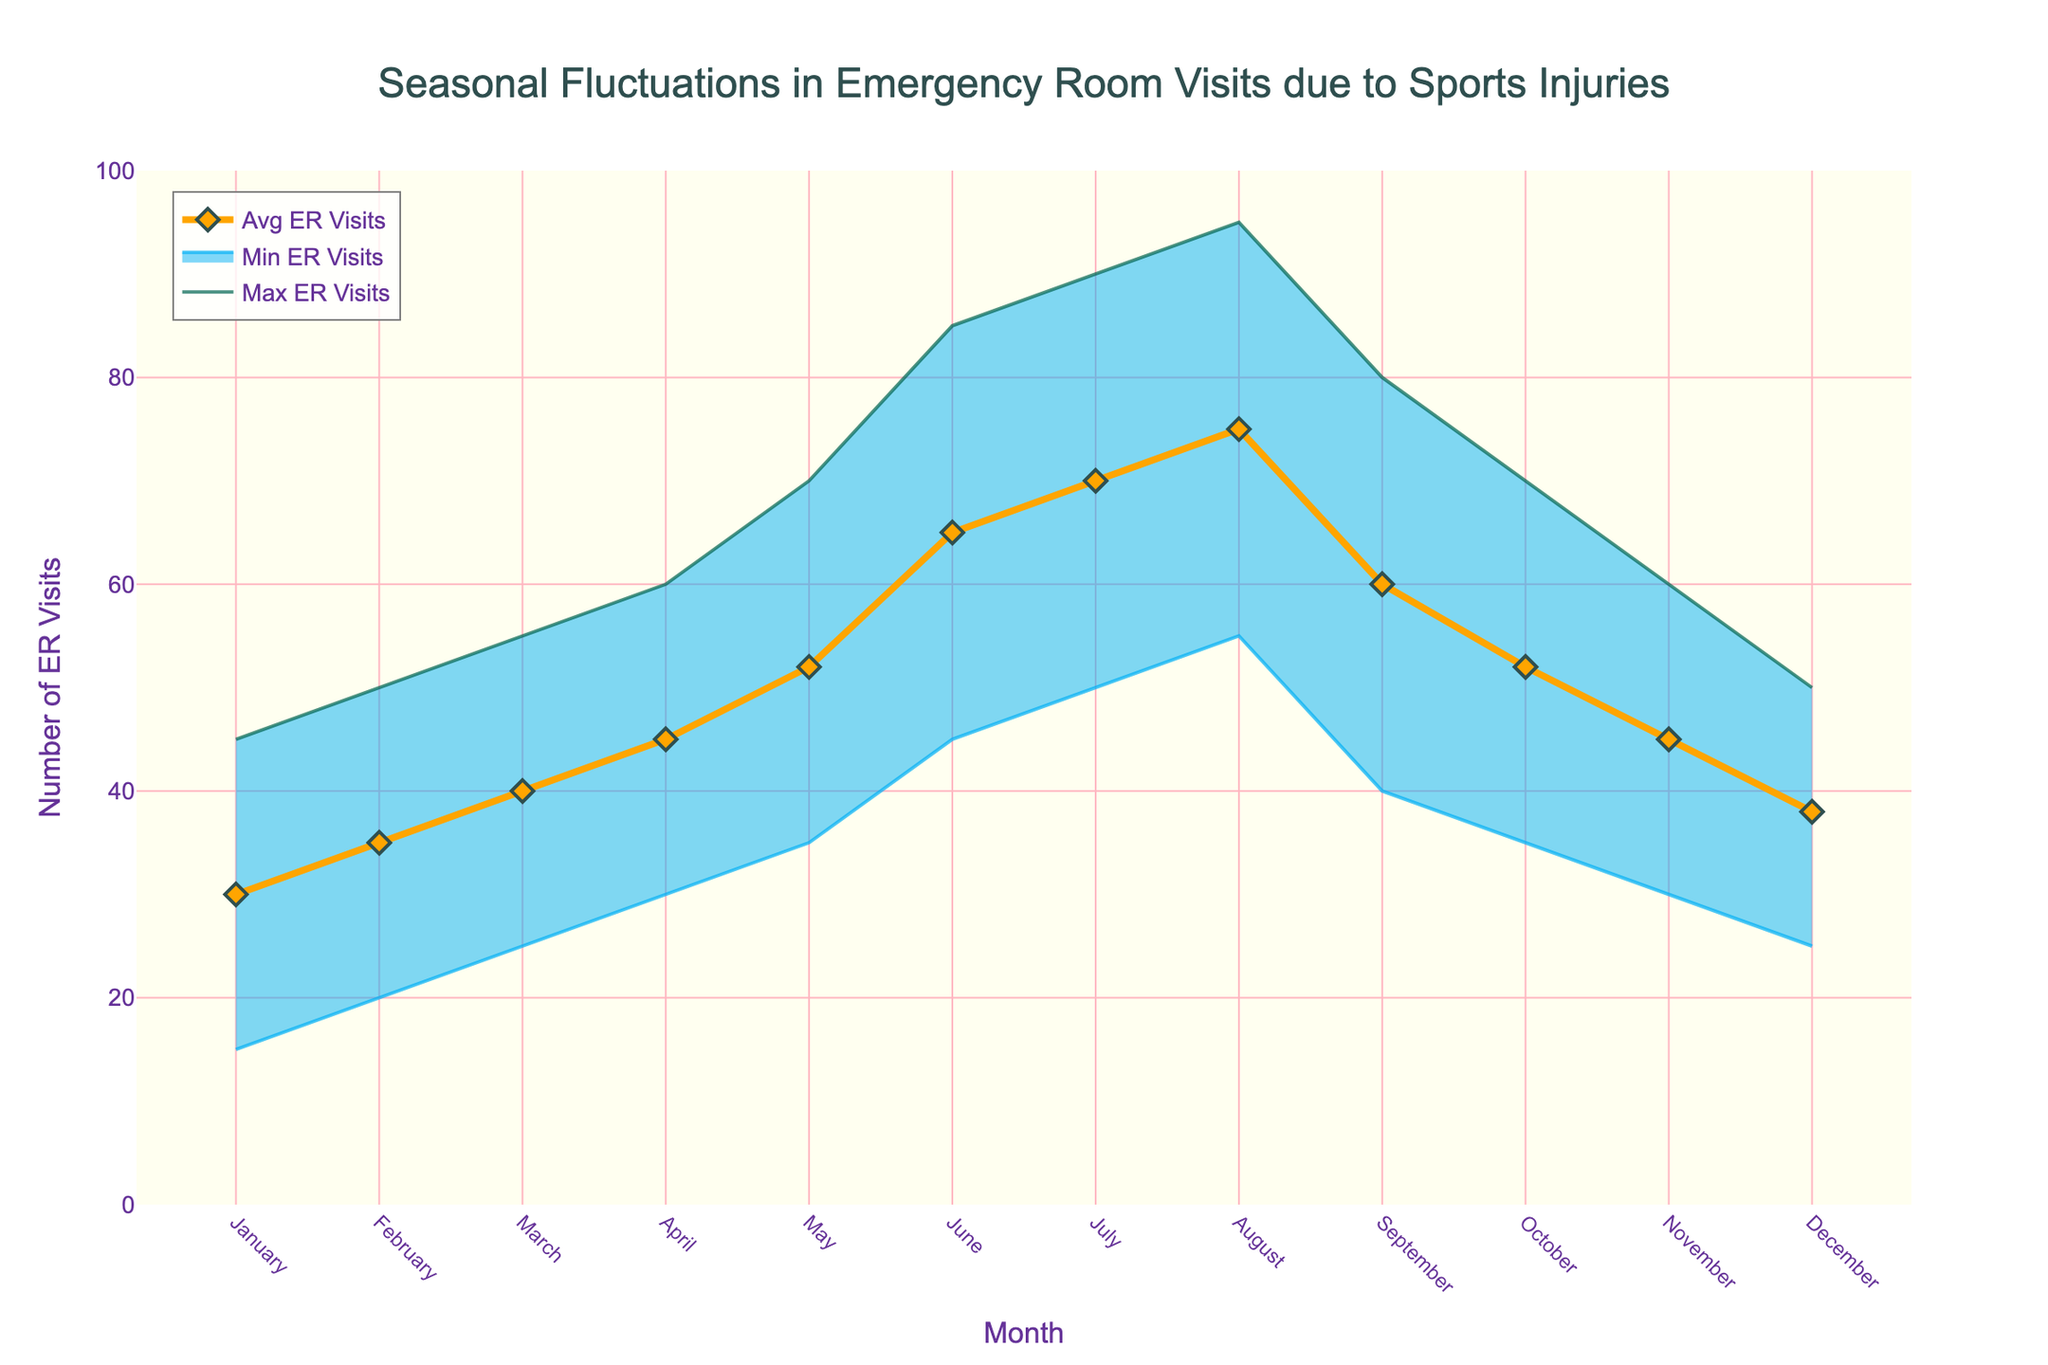What's the title of the figure? The figure's title can be found at the very top and typically encompasses the overarching theme or focus of the graph.
Answer: Seasonal Fluctuations in Emergency Room Visits due to Sports Injuries What are the y-axis and x-axis titles? The titles of the y-axis and x-axis are located near the respective axes and describe what is being measured and the units of the measurements.
Answer: The y-axis title is "Number of ER Visits" and the x-axis title is "Month" During which month is the difference between the maximum and minimum number of ER visits the largest? To determine the month with the largest difference between maximum and minimum ER visits, we need to find the month where the subtraction (Max ER Visits - Min ER Visits) is the highest. The data shows the largest difference (95 - 55 = 40) in August.
Answer: August Which months have the same average number of ER visits? To find the months with the same average ER visits, we compare the average values across all months. From the data, we can see that May and October both have an average of 52 ER visits.
Answer: May and October What is the general trend of average ER visits from January to December? To describe the general trend, we observe the average values: the average number of ER visits starts at 30 in January, generally increases to a peak in August (75), and then decreases again by December (38).
Answer: Increase to August, then decrease Which month experiences the least fluctuation in ER visits? The month with the least fluctuation in ER visits is identified by finding the smallest difference between the max and min values (range). The month with the smallest fluctuation is January (45 - 15 = 30).
Answer: January How many months have an average number of ER visits less than 40? To answer this, we count the months with average ER visits below 40 from the dataset: January (30), February (35), and December (38). So, there are 3 months.
Answer: 3 months During which months did the average number of ER visits exceed 60? Observing the months where Avg ER Visits > 60 reveals that June (65), July (70), and August (75) meet this criterion.
Answer: June, July, and August What is the difference in average ER visits between December and January? To find this, we subtract the average ER visits of January (30) from December (38). The difference is 38 - 30 = 8.
Answer: 8 In which month is the maximum number of ER visits the highest, and what is the value? By comparing the max ER visits across months, August has the highest value at 95 ER visits.
Answer: August, 95 